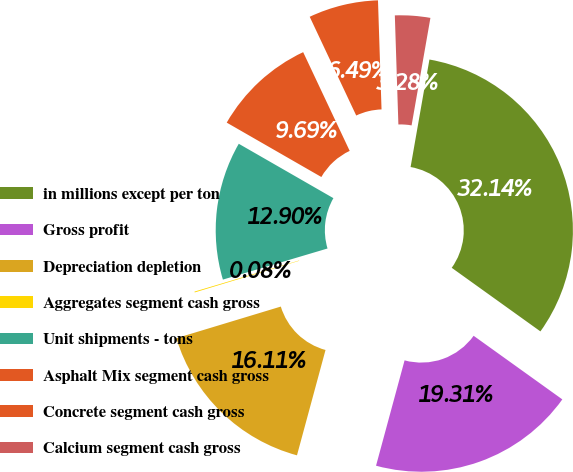<chart> <loc_0><loc_0><loc_500><loc_500><pie_chart><fcel>in millions except per ton<fcel>Gross profit<fcel>Depreciation depletion<fcel>Aggregates segment cash gross<fcel>Unit shipments - tons<fcel>Asphalt Mix segment cash gross<fcel>Concrete segment cash gross<fcel>Calcium segment cash gross<nl><fcel>32.14%<fcel>19.31%<fcel>16.11%<fcel>0.08%<fcel>12.9%<fcel>9.69%<fcel>6.49%<fcel>3.28%<nl></chart> 